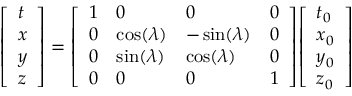Convert formula to latex. <formula><loc_0><loc_0><loc_500><loc_500>{ \left [ \begin{array} { l } { t } \\ { x } \\ { y } \\ { z } \end{array} \right ] } = { \left [ \begin{array} { l l l l } { 1 } & { 0 } & { 0 } & { 0 } \\ { 0 } & { \cos ( \lambda ) } & { - \sin ( \lambda ) } & { 0 } \\ { 0 } & { \sin ( \lambda ) } & { \cos ( \lambda ) } & { 0 } \\ { 0 } & { 0 } & { 0 } & { 1 } \end{array} \right ] } { \left [ \begin{array} { l } { t _ { 0 } } \\ { x _ { 0 } } \\ { y _ { 0 } } \\ { z _ { 0 } } \end{array} \right ] }</formula> 